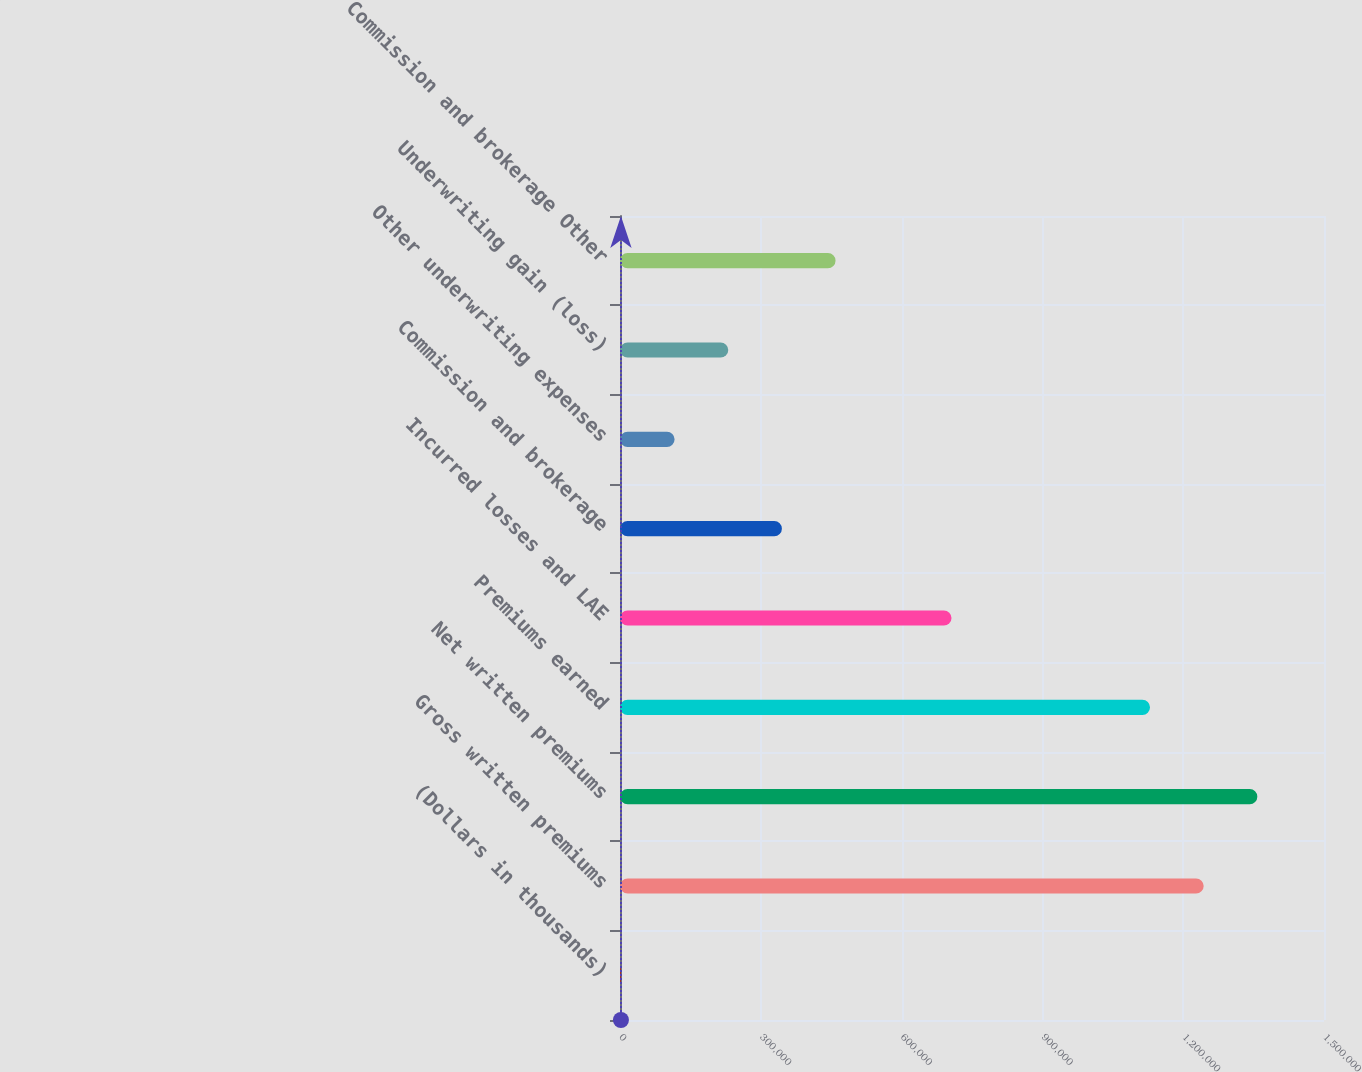Convert chart to OTSL. <chart><loc_0><loc_0><loc_500><loc_500><bar_chart><fcel>(Dollars in thousands)<fcel>Gross written premiums<fcel>Net written premiums<fcel>Premiums earned<fcel>Incurred losses and LAE<fcel>Commission and brokerage<fcel>Other underwriting expenses<fcel>Underwriting gain (loss)<fcel>Commission and brokerage Other<nl><fcel>2010<fcel>1.24364e+06<fcel>1.35796e+06<fcel>1.12933e+06<fcel>706314<fcel>344954<fcel>116325<fcel>230640<fcel>459269<nl></chart> 